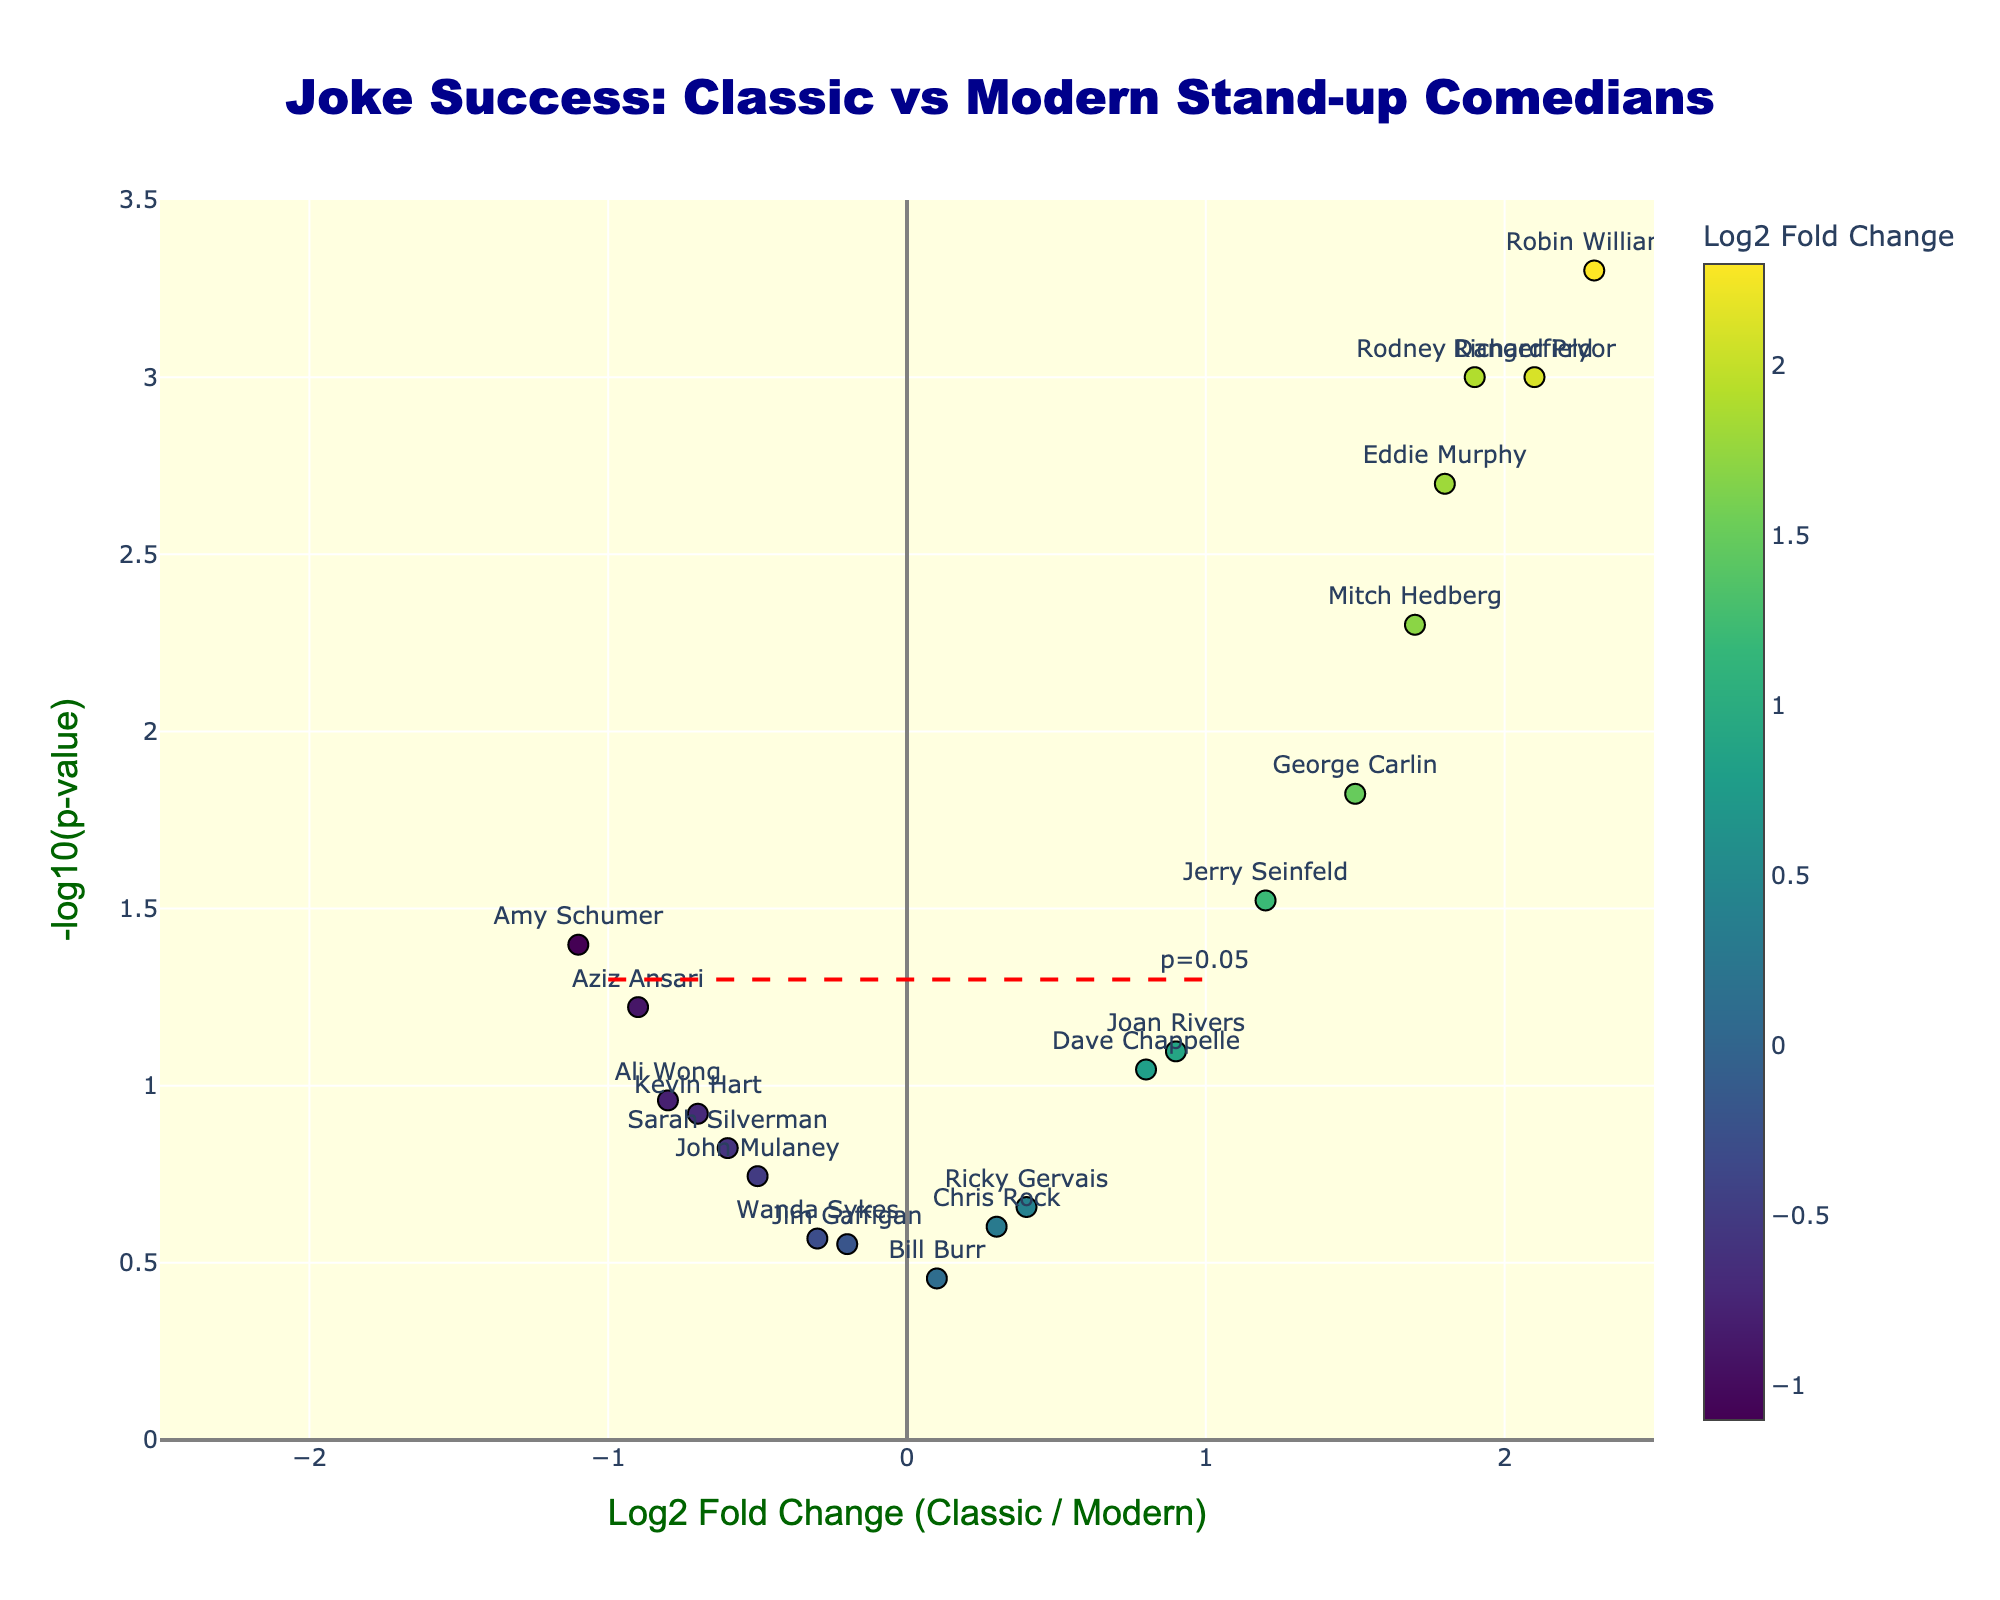what is the title of the figure? The title of a figure is typically displayed at the top, providing a brief description of what the data represents. In this case, the title is "Joke Success: Classic vs Modern Stand-up Comedians".
Answer: Joke Success: Classic vs Modern Stand-up Comedians What is the x-axis labeled? The x-axis label is usually at the bottom of the figure, describing what the horizontal axis measures. Here, it indicates "Log2 Fold Change (Classic / Modern)".
Answer: Log2 Fold Change (Classic / Modern) Who has the highest negative Log2 Fold Change? By looking at the data points on the left side of the x-axis (negative side), Amy Schumer has the highest negative log2 fold change value with -1.1.
Answer: Amy Schumer Which comedian has the most significant p-value and what’s their log fold change? The most significant p-value is represented by the highest -log10(p-value) on the y-axis. Robin Williams has the highest value at 2.3 for the log2 fold change and the lowest p-value of 0.0005.
Answer: Robin Williams, 2.3 Which comedians have p-values less than 0.05? Comedians with -log10(p-value) above 1.3 line have p-values less than 0.05. These include Robin Williams, Richard Pryor, Rodney Dangerfield, Eddie Murphy, Mitch Hedberg, and George Carlin.
Answer: Robin Williams, Richard Pryor, Rodney Dangerfield, Eddie Murphy, Mitch Hedberg, George Carlin How many comedians have a positive Log2 Fold Change and significant p-value? Positive Log2 Fold Change values are on the right side of the plot. For significance, check if they are above the red dashed line (p-value < 0.05). Jerry Seinfeld, Eddie Murphy, Richard Pryor, George Carlin, Mitch Hedberg, and Rodney Dangerfield meet both criteria.
Answer: 6 comedians Which comedian has a Log2 Fold Change close to zero but a non-significant p-value? A Log2 Fold Change close to zero centers around the vertical axis. Bill Burr has a Log2 Fold Change of almost 0 (0.1) and a non-significant p-value (0.35).
Answer: Bill Burr Compare the Log2 Fold Change of Joan Rivers and John Mulaney. Who has the higher value? Joan Rivers has a Log2 Fold Change of 0.9 while John Mulaney has -0.5. Hence, Joan Rivers has a higher value.
Answer: Joan Rivers Which comedians are located in the upper-right quadrant of the plot? The upper-right quadrant indicates comedians with positive Log2 Fold Change and significant p-values. Eddie Murphy, Richard Pryor, Robin Williams, Rodney Dangerfield, Mitch Hedberg, and George Carlin are located here.
Answer: Eddie Murphy, Richard Pryor, Robin Williams, Rodney Dangerfield, Mitch Hedberg, George Carlin 